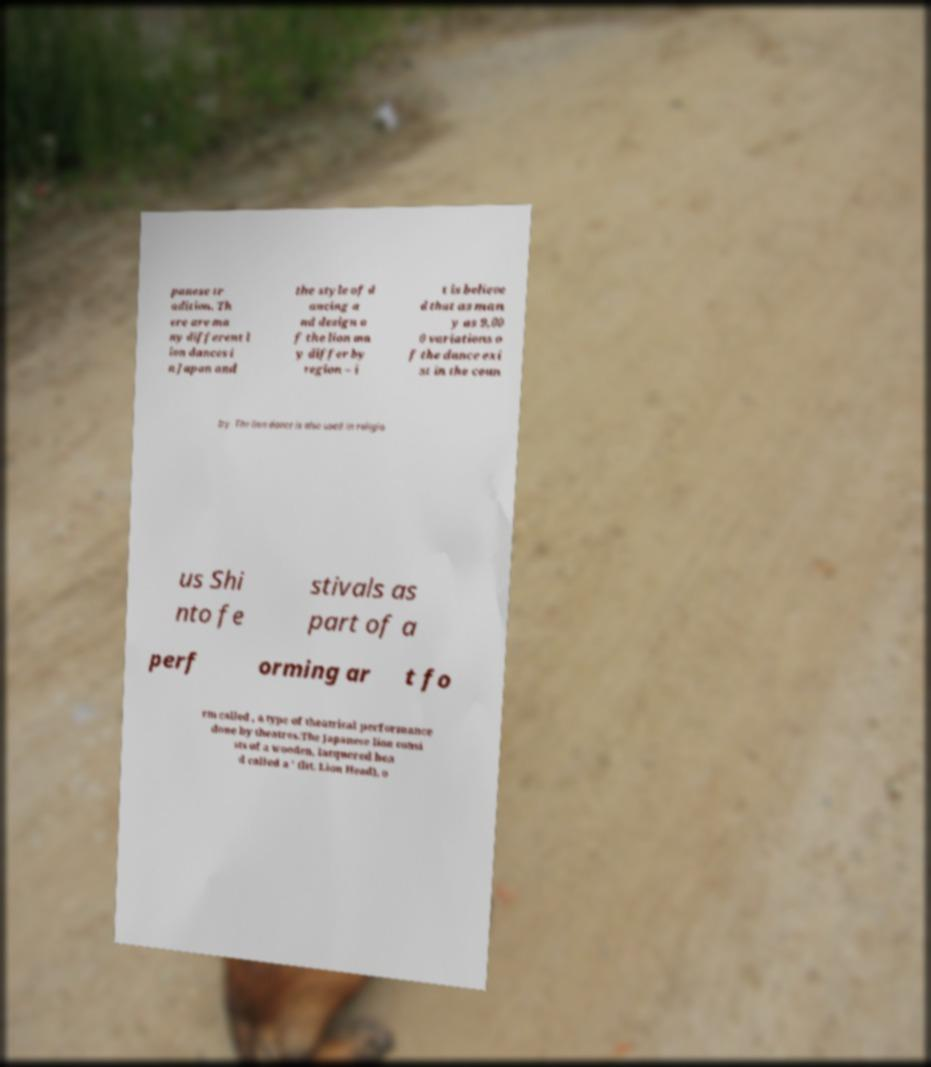Could you assist in decoding the text presented in this image and type it out clearly? panese tr adition. Th ere are ma ny different l ion dances i n Japan and the style of d ancing a nd design o f the lion ma y differ by region – i t is believe d that as man y as 9,00 0 variations o f the dance exi st in the coun try. The lion dance is also used in religio us Shi nto fe stivals as part of a perf orming ar t fo rm called , a type of theatrical performance done by theatres.The Japanese lion consi sts of a wooden, lacquered hea d called a ' (lit. Lion Head), o 